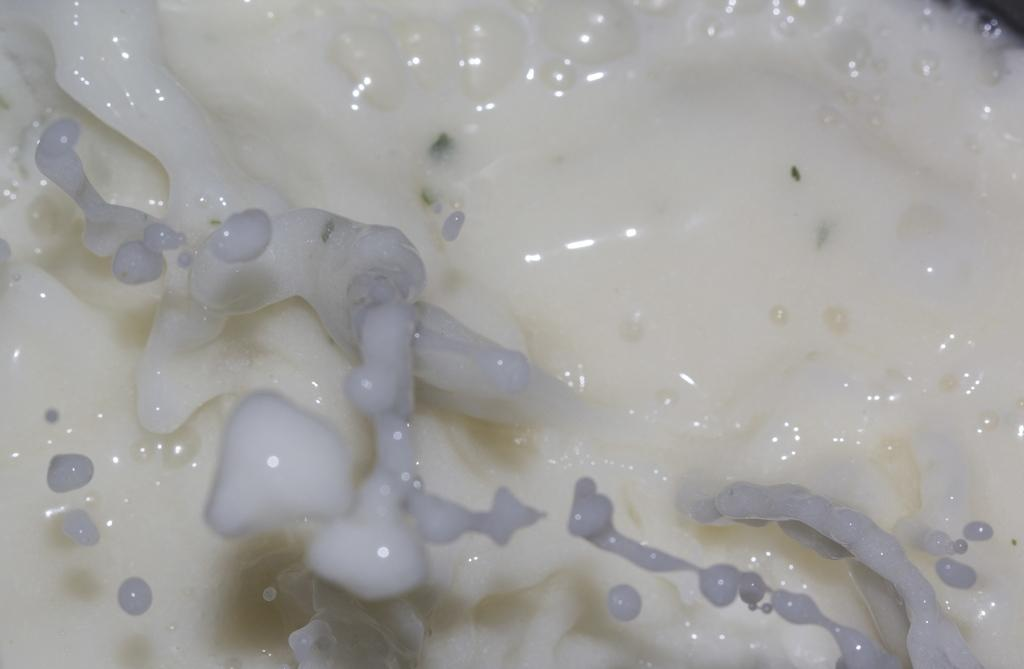What is the main subject in the image? There is a white-colored thing in the image. What can be found inside the white-colored thing? The white-colored thing contains bubbles. How does the goose interact with the camera in the image? There is no goose or camera present in the image. What type of class is being taught in the image? There is no class or teaching activity depicted in the image. 